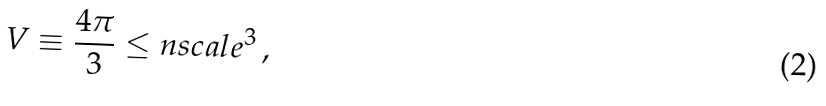<formula> <loc_0><loc_0><loc_500><loc_500>V \equiv \frac { 4 \pi } { 3 } \leq n s c a l e ^ { 3 } \, ,</formula> 